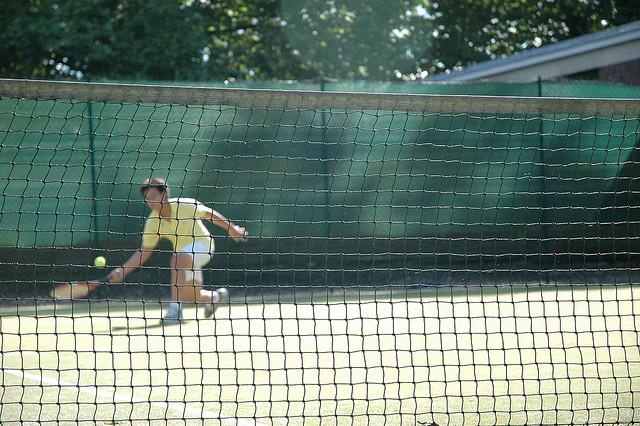Is the ball on the ground?
Answer briefly. No. What is being played?
Concise answer only. Tennis. What color is the man's shirt?
Short answer required. Yellow. 